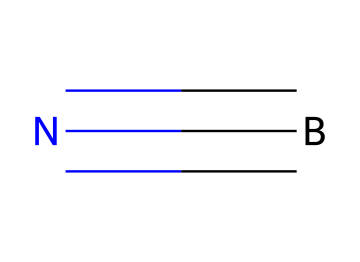What is the total number of atoms in this molecule? There are two distinct elements in this chemical: boron (B) and nitrogen (N). Counting the atoms, there is one boron atom and one nitrogen atom. Thus, the total number of atoms is 2.
Answer: 2 How many bonds are present in the structure? The structure consists of a triple bond between boron and nitrogen. Since a triple bond is made up of three bonds, there are a total of 3 bonds in the molecule.
Answer: 3 What is the name of the compound represented by this structure? The structure, which contains one boron atom and one nitrogen atom, corresponds to boron nitride. Therefore, the name of the compound is boron nitride.
Answer: boron nitride Is boron nitride ionic or covalent? The bond between boron and nitrogen in this structure exhibits characteristics of covalent bonding, as indicated by the sharing of electrons in the triple bond. Thus, boron nitride is classified as covalent.
Answer: covalent What type of bond is found between the boron and nitrogen atoms? The chemical structure shows that boron (B) and nitrogen (N) are connected by a triple bond, which indicates that they share three pairs of electrons. Therefore, this bond is a triple bond.
Answer: triple bond Why might boron nitride be used in cochlear implant materials? Boron nitride has properties such as biocompatibility and thermal stability, which are essential for materials used in medical implants, including cochlear implants. Questions about material safety and stability in biological environments lead to this conclusion.
Answer: biocompatibility and thermal stability 